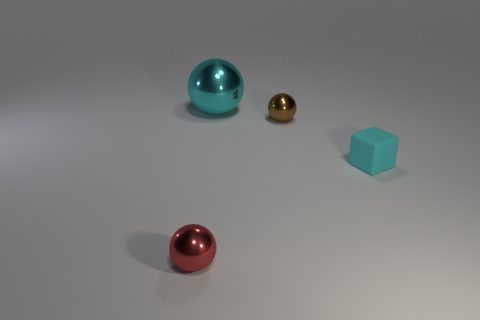How many other things are there of the same size as the red sphere?
Your answer should be very brief. 2. Does the small brown ball have the same material as the red sphere?
Offer a very short reply. Yes. There is a tiny metallic thing on the left side of the metallic object behind the small brown thing; what color is it?
Ensure brevity in your answer.  Red. What size is the brown metallic object that is the same shape as the tiny red metal object?
Keep it short and to the point. Small. Is the tiny block the same color as the large metal thing?
Offer a terse response. Yes. There is a ball behind the tiny sphere that is to the right of the large cyan thing; how many small red shiny objects are in front of it?
Offer a terse response. 1. Are there more small rubber objects than tiny green metal things?
Make the answer very short. Yes. What number of red things are there?
Offer a very short reply. 1. There is a small shiny object in front of the small shiny ball that is behind the metal sphere that is in front of the brown thing; what is its shape?
Make the answer very short. Sphere. Is the number of brown metal things that are on the left side of the brown metal object less than the number of tiny matte things behind the tiny red sphere?
Provide a short and direct response. Yes. 